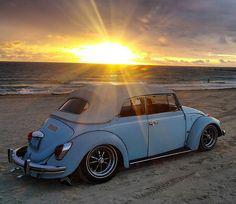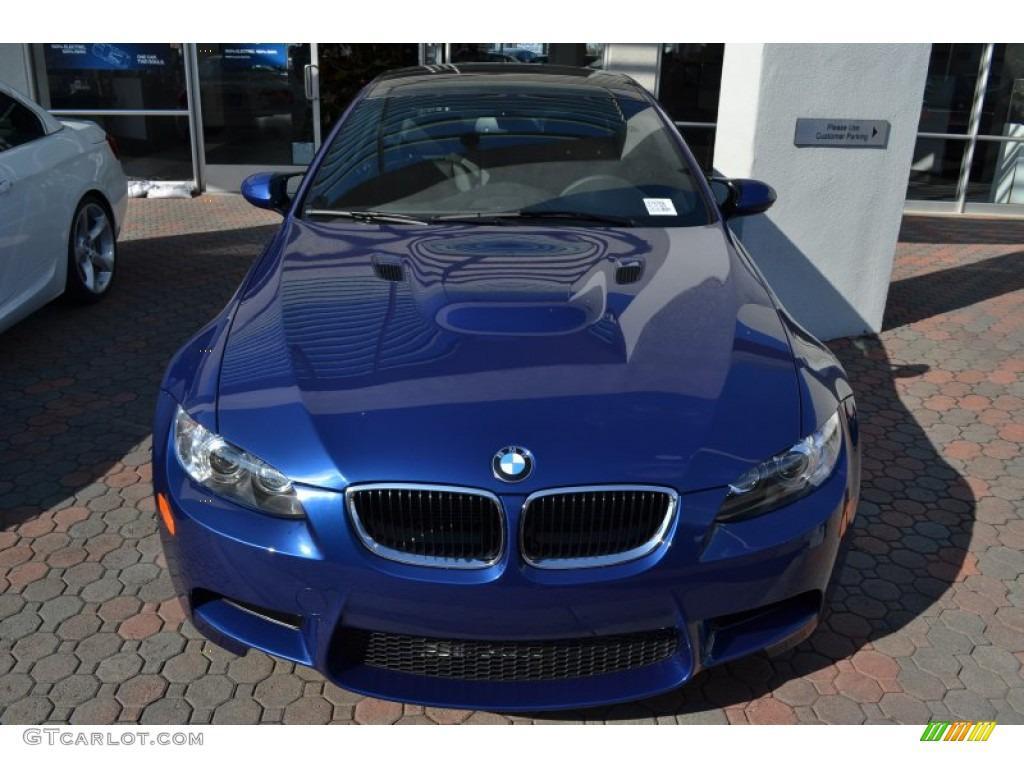The first image is the image on the left, the second image is the image on the right. For the images shown, is this caption "The left image contains a royal blue topless convertible displayed at an angle on a gray surface." true? Answer yes or no. No. The first image is the image on the left, the second image is the image on the right. Evaluate the accuracy of this statement regarding the images: "In both images the car has it's top down.". Is it true? Answer yes or no. No. 